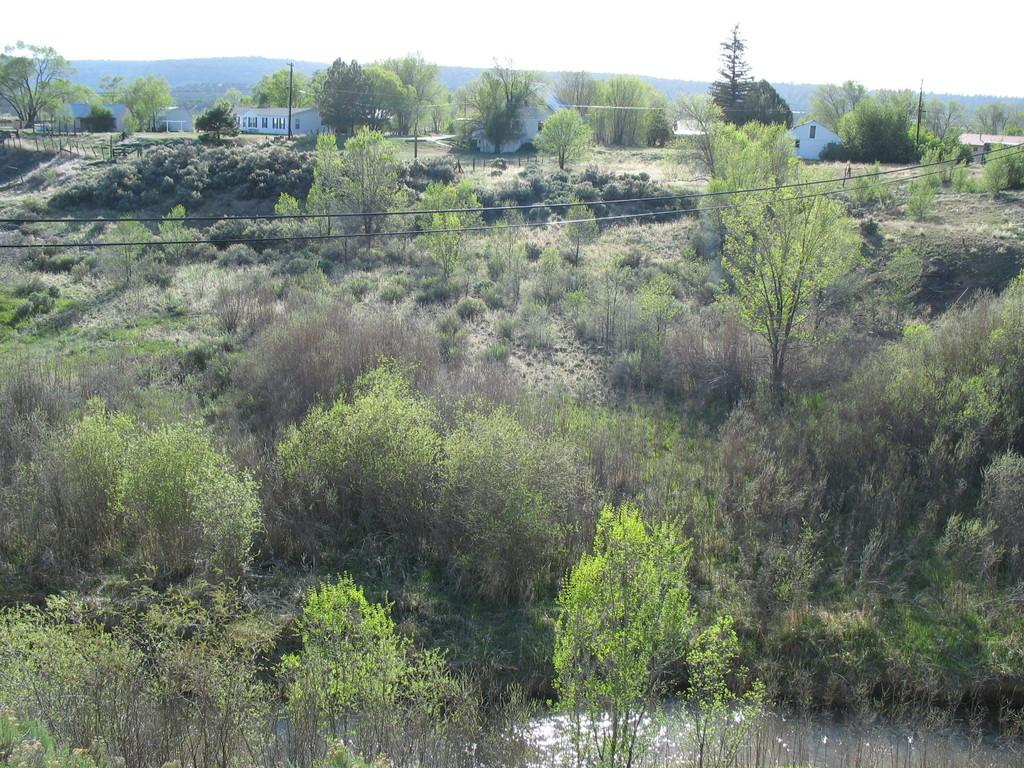What type of vegetation can be seen in the image? There are plants and trees in the image. What type of structures are visible in the background of the image? There are homes in the background of the image. What part of the natural environment is visible in the image? The sky is visible in the image. Can you see any crackers floating in the river in the image? There is no river or crackers present in the image. What type of face can be seen on the tree in the image? There is no face present on the trees in the image. 